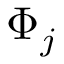Convert formula to latex. <formula><loc_0><loc_0><loc_500><loc_500>\Phi _ { j }</formula> 